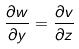Convert formula to latex. <formula><loc_0><loc_0><loc_500><loc_500>\frac { \partial w } { \partial y } = \frac { \partial v } { \partial z }</formula> 